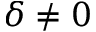<formula> <loc_0><loc_0><loc_500><loc_500>\delta \neq 0</formula> 